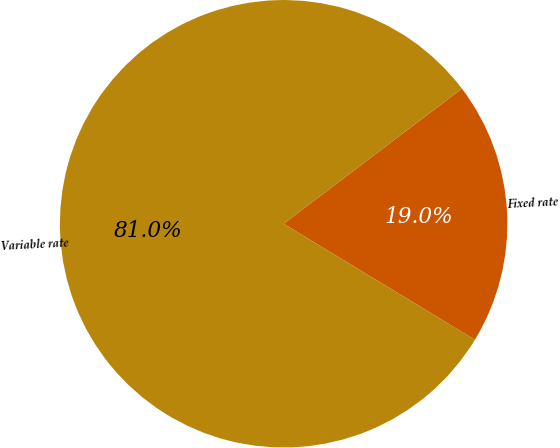Convert chart. <chart><loc_0><loc_0><loc_500><loc_500><pie_chart><fcel>Fixed rate<fcel>Variable rate<nl><fcel>19.0%<fcel>81.0%<nl></chart> 